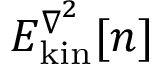<formula> <loc_0><loc_0><loc_500><loc_500>E _ { k i n } ^ { \nabla ^ { 2 } } [ n ]</formula> 